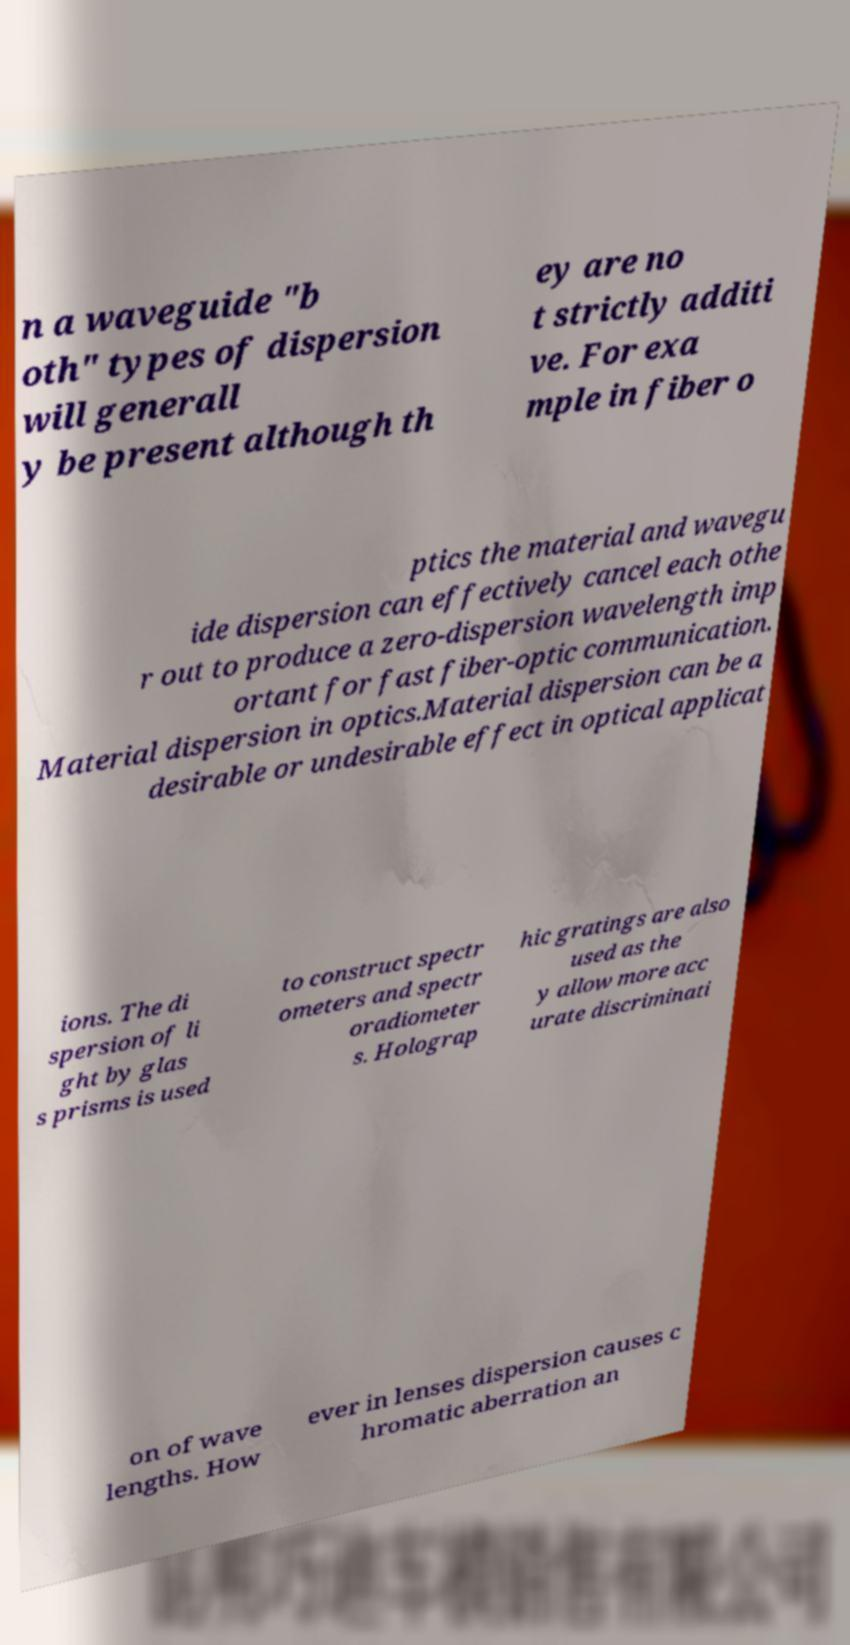Can you accurately transcribe the text from the provided image for me? n a waveguide "b oth" types of dispersion will generall y be present although th ey are no t strictly additi ve. For exa mple in fiber o ptics the material and wavegu ide dispersion can effectively cancel each othe r out to produce a zero-dispersion wavelength imp ortant for fast fiber-optic communication. Material dispersion in optics.Material dispersion can be a desirable or undesirable effect in optical applicat ions. The di spersion of li ght by glas s prisms is used to construct spectr ometers and spectr oradiometer s. Holograp hic gratings are also used as the y allow more acc urate discriminati on of wave lengths. How ever in lenses dispersion causes c hromatic aberration an 